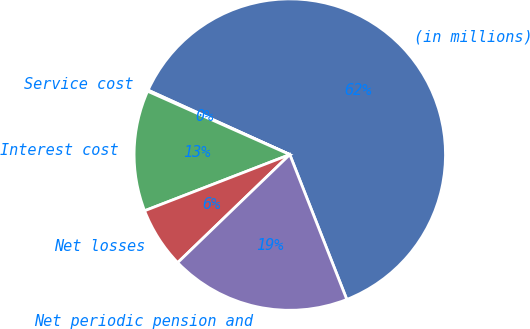Convert chart to OTSL. <chart><loc_0><loc_0><loc_500><loc_500><pie_chart><fcel>(in millions)<fcel>Service cost<fcel>Interest cost<fcel>Net losses<fcel>Net periodic pension and<nl><fcel>62.24%<fcel>0.12%<fcel>12.55%<fcel>6.33%<fcel>18.76%<nl></chart> 